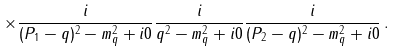<formula> <loc_0><loc_0><loc_500><loc_500>\times \frac { i } { ( P _ { 1 } - q ) ^ { 2 } - m _ { q } ^ { 2 } + i 0 } \frac { i } { q ^ { 2 } - m _ { q } ^ { 2 } + i 0 } \frac { i } { ( P _ { 2 } - q ) ^ { 2 } - m _ { q } ^ { 2 } + i 0 } \, .</formula> 